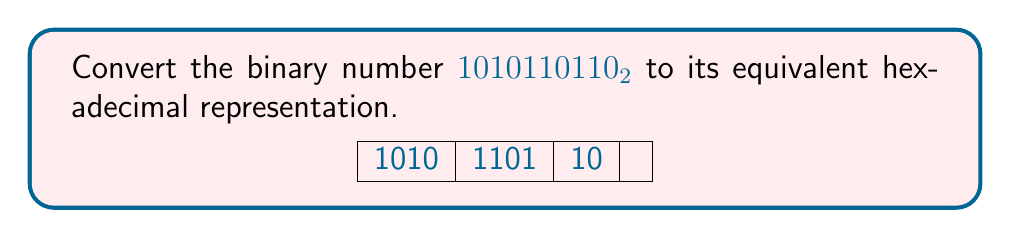What is the answer to this math problem? To convert a binary number to hexadecimal, we can follow these steps:

1. Group the binary digits into sets of 4, starting from the right:
   $$1010110110_2 = 1\,0101\,1011\,0_2$$

2. Convert each group of 4 binary digits to its hexadecimal equivalent:

   For the rightmost group: $0000_2 = 0_{16}$
   For the next group: $1011_2 = 11_{10} = B_{16}$
   For the third group: $0101_2 = 5_{16}$
   For the leftmost group: $0001_2 = 1_{16}$

3. Combine the hexadecimal digits:
   $$1\,0101\,1011\,0_2 = 15B0_{16}$$

Therefore, the binary number $1010110110_2$ is equivalent to $15B0_{16}$ in hexadecimal.
Answer: $15B0_{16}$ 